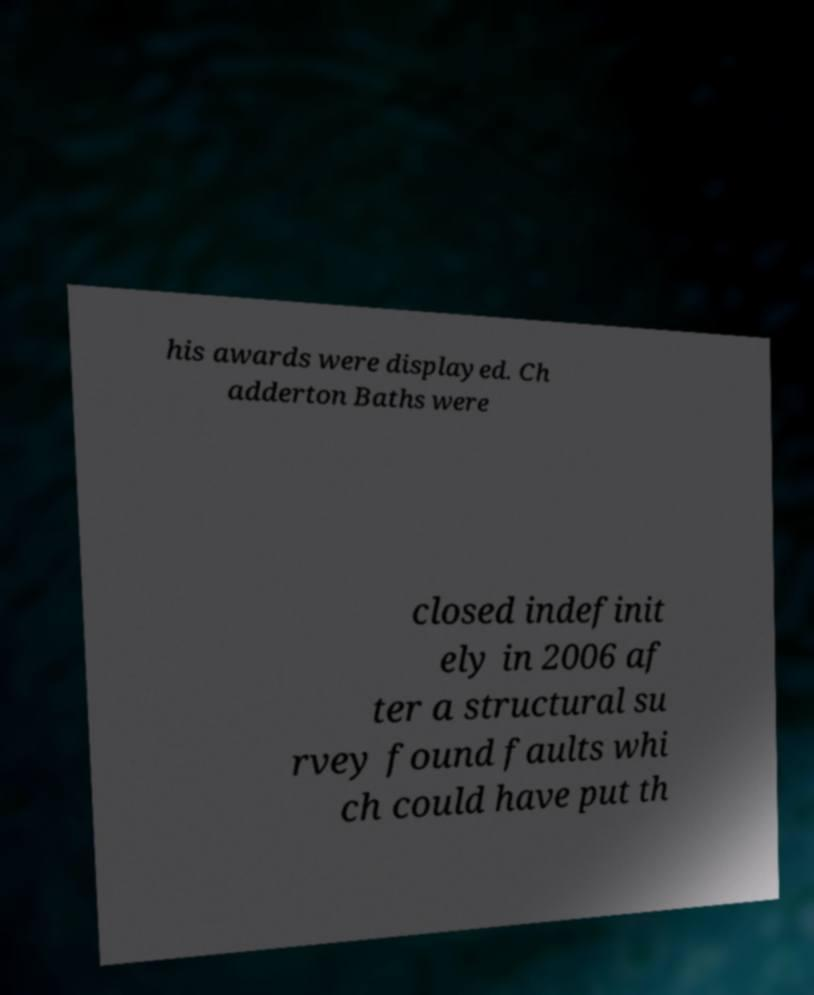Please read and relay the text visible in this image. What does it say? his awards were displayed. Ch adderton Baths were closed indefinit ely in 2006 af ter a structural su rvey found faults whi ch could have put th 